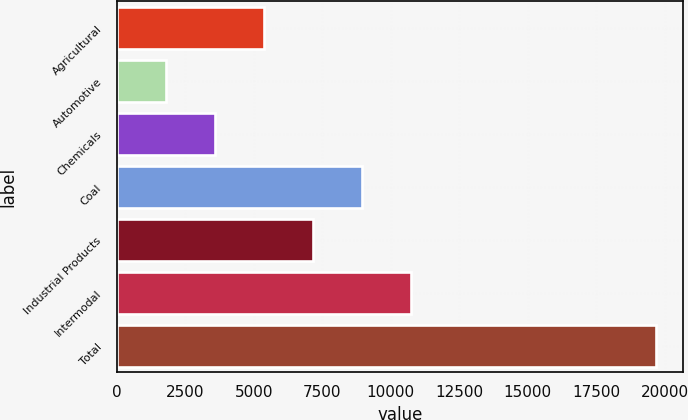<chart> <loc_0><loc_0><loc_500><loc_500><bar_chart><fcel>Agricultural<fcel>Automotive<fcel>Chemicals<fcel>Coal<fcel>Industrial Products<fcel>Intermodal<fcel>Total<nl><fcel>5382.8<fcel>1807<fcel>3594.9<fcel>8958.6<fcel>7170.7<fcel>10746.5<fcel>19686<nl></chart> 